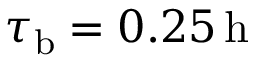<formula> <loc_0><loc_0><loc_500><loc_500>\tau _ { b } = 0 . 2 5 \, h</formula> 